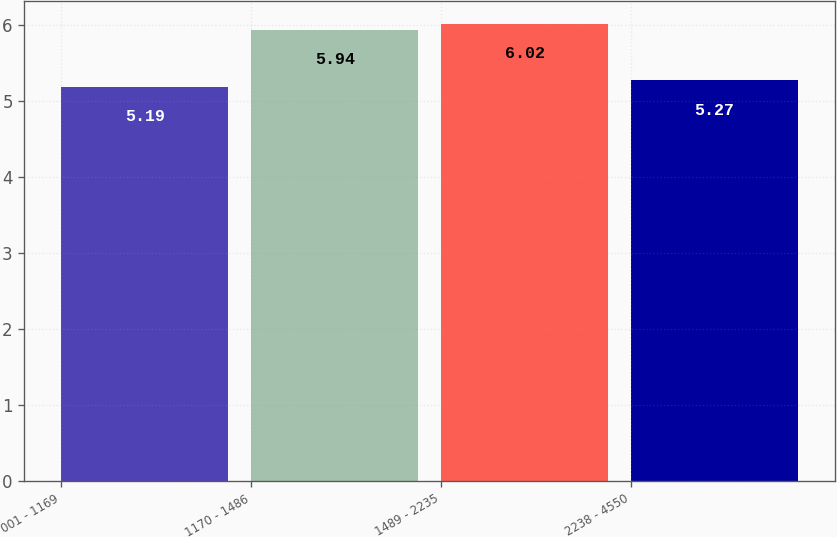Convert chart to OTSL. <chart><loc_0><loc_0><loc_500><loc_500><bar_chart><fcel>001 - 1169<fcel>1170 - 1486<fcel>1489 - 2235<fcel>2238 - 4550<nl><fcel>5.19<fcel>5.94<fcel>6.02<fcel>5.27<nl></chart> 